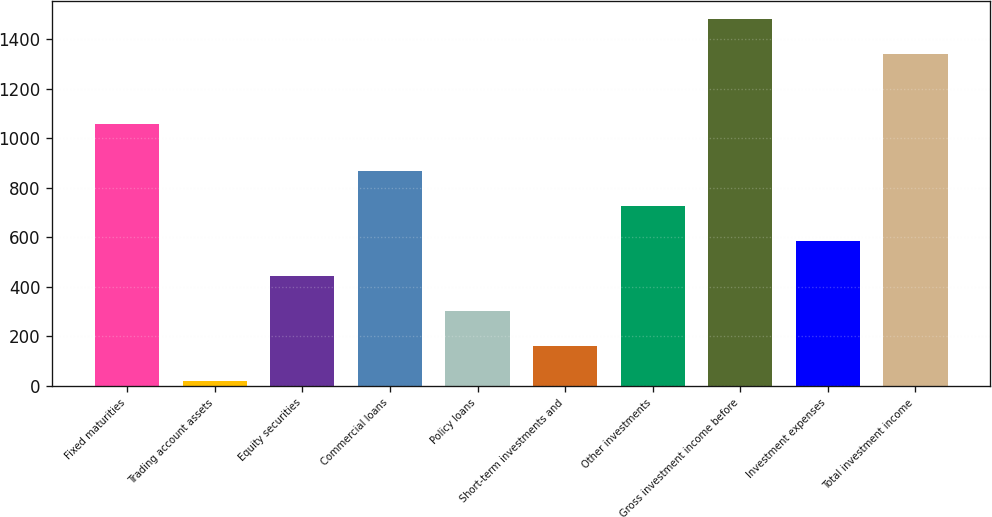<chart> <loc_0><loc_0><loc_500><loc_500><bar_chart><fcel>Fixed maturities<fcel>Trading account assets<fcel>Equity securities<fcel>Commercial loans<fcel>Policy loans<fcel>Short-term investments and<fcel>Other investments<fcel>Gross investment income before<fcel>Investment expenses<fcel>Total investment income<nl><fcel>1058<fcel>19<fcel>443.8<fcel>868.6<fcel>302.2<fcel>160.6<fcel>727<fcel>1480.6<fcel>585.4<fcel>1339<nl></chart> 